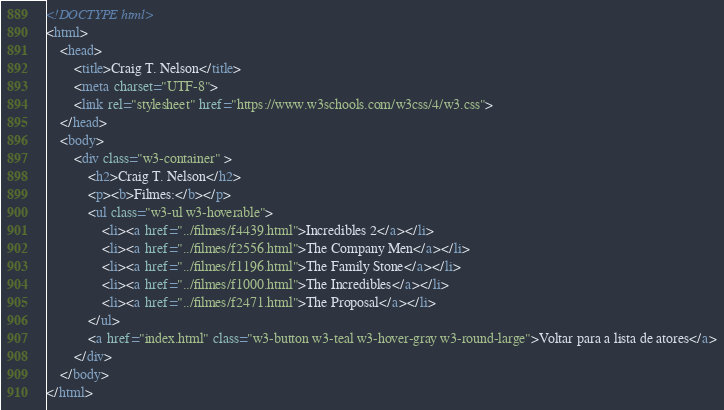<code> <loc_0><loc_0><loc_500><loc_500><_HTML_><!DOCTYPE html>
<html>
    <head>
        <title>Craig T. Nelson</title>
        <meta charset="UTF-8">
        <link rel="stylesheet" href="https://www.w3schools.com/w3css/4/w3.css">
    </head>
    <body>
        <div class="w3-container" >
            <h2>Craig T. Nelson</h2>
            <p><b>Filmes:</b></p>
            <ul class="w3-ul w3-hoverable">
				<li><a href="../filmes/f4439.html">Incredibles 2</a></li>
				<li><a href="../filmes/f2556.html">The Company Men</a></li>
				<li><a href="../filmes/f1196.html">The Family Stone</a></li>
				<li><a href="../filmes/f1000.html">The Incredibles</a></li>
				<li><a href="../filmes/f2471.html">The Proposal</a></li>
			</ul>
            <a href="index.html" class="w3-button w3-teal w3-hover-gray w3-round-large">Voltar para a lista de atores</a>
        </div>
    </body>
</html></code> 